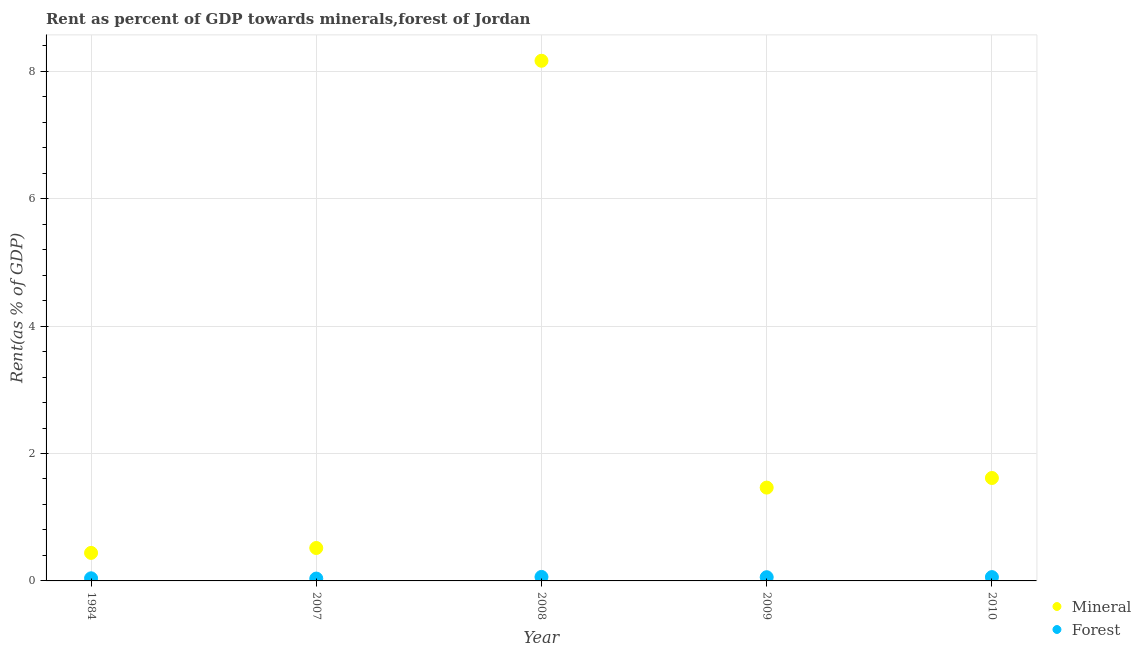How many different coloured dotlines are there?
Your response must be concise. 2. What is the mineral rent in 2009?
Keep it short and to the point. 1.46. Across all years, what is the maximum mineral rent?
Offer a very short reply. 8.16. Across all years, what is the minimum forest rent?
Offer a terse response. 0.04. What is the total mineral rent in the graph?
Provide a short and direct response. 12.2. What is the difference between the mineral rent in 1984 and that in 2007?
Keep it short and to the point. -0.08. What is the difference between the mineral rent in 1984 and the forest rent in 2008?
Provide a short and direct response. 0.38. What is the average forest rent per year?
Give a very brief answer. 0.05. In the year 2010, what is the difference between the forest rent and mineral rent?
Make the answer very short. -1.56. What is the ratio of the mineral rent in 2009 to that in 2010?
Give a very brief answer. 0.91. Is the mineral rent in 1984 less than that in 2009?
Your answer should be compact. Yes. What is the difference between the highest and the second highest mineral rent?
Provide a succinct answer. 6.55. What is the difference between the highest and the lowest mineral rent?
Make the answer very short. 7.72. Does the mineral rent monotonically increase over the years?
Your answer should be compact. No. Is the mineral rent strictly greater than the forest rent over the years?
Provide a short and direct response. Yes. Is the forest rent strictly less than the mineral rent over the years?
Keep it short and to the point. Yes. Are the values on the major ticks of Y-axis written in scientific E-notation?
Provide a succinct answer. No. Does the graph contain grids?
Offer a very short reply. Yes. Where does the legend appear in the graph?
Make the answer very short. Bottom right. How are the legend labels stacked?
Provide a succinct answer. Vertical. What is the title of the graph?
Make the answer very short. Rent as percent of GDP towards minerals,forest of Jordan. What is the label or title of the Y-axis?
Give a very brief answer. Rent(as % of GDP). What is the Rent(as % of GDP) of Mineral in 1984?
Offer a terse response. 0.44. What is the Rent(as % of GDP) of Forest in 1984?
Your answer should be compact. 0.04. What is the Rent(as % of GDP) of Mineral in 2007?
Keep it short and to the point. 0.52. What is the Rent(as % of GDP) in Forest in 2007?
Offer a very short reply. 0.04. What is the Rent(as % of GDP) in Mineral in 2008?
Your answer should be very brief. 8.16. What is the Rent(as % of GDP) in Forest in 2008?
Ensure brevity in your answer.  0.06. What is the Rent(as % of GDP) of Mineral in 2009?
Ensure brevity in your answer.  1.46. What is the Rent(as % of GDP) of Forest in 2009?
Give a very brief answer. 0.06. What is the Rent(as % of GDP) in Mineral in 2010?
Keep it short and to the point. 1.62. What is the Rent(as % of GDP) of Forest in 2010?
Your response must be concise. 0.06. Across all years, what is the maximum Rent(as % of GDP) in Mineral?
Your response must be concise. 8.16. Across all years, what is the maximum Rent(as % of GDP) of Forest?
Your response must be concise. 0.06. Across all years, what is the minimum Rent(as % of GDP) of Mineral?
Your answer should be compact. 0.44. Across all years, what is the minimum Rent(as % of GDP) of Forest?
Provide a short and direct response. 0.04. What is the total Rent(as % of GDP) of Mineral in the graph?
Ensure brevity in your answer.  12.2. What is the total Rent(as % of GDP) in Forest in the graph?
Provide a short and direct response. 0.26. What is the difference between the Rent(as % of GDP) of Mineral in 1984 and that in 2007?
Offer a terse response. -0.08. What is the difference between the Rent(as % of GDP) of Forest in 1984 and that in 2007?
Keep it short and to the point. 0. What is the difference between the Rent(as % of GDP) of Mineral in 1984 and that in 2008?
Provide a short and direct response. -7.72. What is the difference between the Rent(as % of GDP) in Forest in 1984 and that in 2008?
Your answer should be very brief. -0.02. What is the difference between the Rent(as % of GDP) in Mineral in 1984 and that in 2009?
Offer a very short reply. -1.02. What is the difference between the Rent(as % of GDP) in Forest in 1984 and that in 2009?
Make the answer very short. -0.02. What is the difference between the Rent(as % of GDP) of Mineral in 1984 and that in 2010?
Offer a terse response. -1.18. What is the difference between the Rent(as % of GDP) in Forest in 1984 and that in 2010?
Keep it short and to the point. -0.02. What is the difference between the Rent(as % of GDP) of Mineral in 2007 and that in 2008?
Your answer should be very brief. -7.65. What is the difference between the Rent(as % of GDP) of Forest in 2007 and that in 2008?
Keep it short and to the point. -0.03. What is the difference between the Rent(as % of GDP) of Mineral in 2007 and that in 2009?
Your answer should be very brief. -0.95. What is the difference between the Rent(as % of GDP) in Forest in 2007 and that in 2009?
Give a very brief answer. -0.02. What is the difference between the Rent(as % of GDP) in Mineral in 2007 and that in 2010?
Provide a succinct answer. -1.1. What is the difference between the Rent(as % of GDP) in Forest in 2007 and that in 2010?
Provide a short and direct response. -0.02. What is the difference between the Rent(as % of GDP) of Mineral in 2008 and that in 2009?
Provide a short and direct response. 6.7. What is the difference between the Rent(as % of GDP) of Forest in 2008 and that in 2009?
Give a very brief answer. 0. What is the difference between the Rent(as % of GDP) of Mineral in 2008 and that in 2010?
Offer a very short reply. 6.55. What is the difference between the Rent(as % of GDP) in Forest in 2008 and that in 2010?
Make the answer very short. 0. What is the difference between the Rent(as % of GDP) in Mineral in 2009 and that in 2010?
Your answer should be compact. -0.15. What is the difference between the Rent(as % of GDP) in Forest in 2009 and that in 2010?
Offer a terse response. -0. What is the difference between the Rent(as % of GDP) in Mineral in 1984 and the Rent(as % of GDP) in Forest in 2007?
Ensure brevity in your answer.  0.4. What is the difference between the Rent(as % of GDP) of Mineral in 1984 and the Rent(as % of GDP) of Forest in 2008?
Make the answer very short. 0.38. What is the difference between the Rent(as % of GDP) in Mineral in 1984 and the Rent(as % of GDP) in Forest in 2009?
Provide a succinct answer. 0.38. What is the difference between the Rent(as % of GDP) of Mineral in 1984 and the Rent(as % of GDP) of Forest in 2010?
Offer a terse response. 0.38. What is the difference between the Rent(as % of GDP) of Mineral in 2007 and the Rent(as % of GDP) of Forest in 2008?
Ensure brevity in your answer.  0.45. What is the difference between the Rent(as % of GDP) of Mineral in 2007 and the Rent(as % of GDP) of Forest in 2009?
Provide a succinct answer. 0.46. What is the difference between the Rent(as % of GDP) in Mineral in 2007 and the Rent(as % of GDP) in Forest in 2010?
Make the answer very short. 0.46. What is the difference between the Rent(as % of GDP) of Mineral in 2008 and the Rent(as % of GDP) of Forest in 2009?
Provide a short and direct response. 8.11. What is the difference between the Rent(as % of GDP) of Mineral in 2008 and the Rent(as % of GDP) of Forest in 2010?
Your answer should be very brief. 8.1. What is the difference between the Rent(as % of GDP) of Mineral in 2009 and the Rent(as % of GDP) of Forest in 2010?
Your answer should be very brief. 1.4. What is the average Rent(as % of GDP) in Mineral per year?
Offer a very short reply. 2.44. What is the average Rent(as % of GDP) of Forest per year?
Ensure brevity in your answer.  0.05. In the year 1984, what is the difference between the Rent(as % of GDP) in Mineral and Rent(as % of GDP) in Forest?
Your answer should be very brief. 0.4. In the year 2007, what is the difference between the Rent(as % of GDP) of Mineral and Rent(as % of GDP) of Forest?
Give a very brief answer. 0.48. In the year 2008, what is the difference between the Rent(as % of GDP) in Mineral and Rent(as % of GDP) in Forest?
Offer a terse response. 8.1. In the year 2009, what is the difference between the Rent(as % of GDP) in Mineral and Rent(as % of GDP) in Forest?
Give a very brief answer. 1.41. In the year 2010, what is the difference between the Rent(as % of GDP) in Mineral and Rent(as % of GDP) in Forest?
Provide a succinct answer. 1.56. What is the ratio of the Rent(as % of GDP) in Mineral in 1984 to that in 2007?
Provide a succinct answer. 0.85. What is the ratio of the Rent(as % of GDP) of Forest in 1984 to that in 2007?
Offer a very short reply. 1.11. What is the ratio of the Rent(as % of GDP) in Mineral in 1984 to that in 2008?
Your response must be concise. 0.05. What is the ratio of the Rent(as % of GDP) of Forest in 1984 to that in 2008?
Offer a very short reply. 0.66. What is the ratio of the Rent(as % of GDP) of Mineral in 1984 to that in 2009?
Keep it short and to the point. 0.3. What is the ratio of the Rent(as % of GDP) of Forest in 1984 to that in 2009?
Keep it short and to the point. 0.71. What is the ratio of the Rent(as % of GDP) of Mineral in 1984 to that in 2010?
Offer a terse response. 0.27. What is the ratio of the Rent(as % of GDP) of Forest in 1984 to that in 2010?
Provide a short and direct response. 0.69. What is the ratio of the Rent(as % of GDP) in Mineral in 2007 to that in 2008?
Ensure brevity in your answer.  0.06. What is the ratio of the Rent(as % of GDP) of Forest in 2007 to that in 2008?
Offer a very short reply. 0.59. What is the ratio of the Rent(as % of GDP) in Mineral in 2007 to that in 2009?
Offer a very short reply. 0.35. What is the ratio of the Rent(as % of GDP) in Forest in 2007 to that in 2009?
Your answer should be compact. 0.63. What is the ratio of the Rent(as % of GDP) in Mineral in 2007 to that in 2010?
Provide a succinct answer. 0.32. What is the ratio of the Rent(as % of GDP) of Forest in 2007 to that in 2010?
Offer a very short reply. 0.62. What is the ratio of the Rent(as % of GDP) of Mineral in 2008 to that in 2009?
Your response must be concise. 5.57. What is the ratio of the Rent(as % of GDP) of Forest in 2008 to that in 2009?
Give a very brief answer. 1.08. What is the ratio of the Rent(as % of GDP) of Mineral in 2008 to that in 2010?
Offer a very short reply. 5.05. What is the ratio of the Rent(as % of GDP) in Forest in 2008 to that in 2010?
Your response must be concise. 1.05. What is the ratio of the Rent(as % of GDP) in Mineral in 2009 to that in 2010?
Provide a short and direct response. 0.91. What is the ratio of the Rent(as % of GDP) of Forest in 2009 to that in 2010?
Give a very brief answer. 0.97. What is the difference between the highest and the second highest Rent(as % of GDP) in Mineral?
Keep it short and to the point. 6.55. What is the difference between the highest and the second highest Rent(as % of GDP) in Forest?
Make the answer very short. 0. What is the difference between the highest and the lowest Rent(as % of GDP) in Mineral?
Ensure brevity in your answer.  7.72. What is the difference between the highest and the lowest Rent(as % of GDP) in Forest?
Provide a succinct answer. 0.03. 